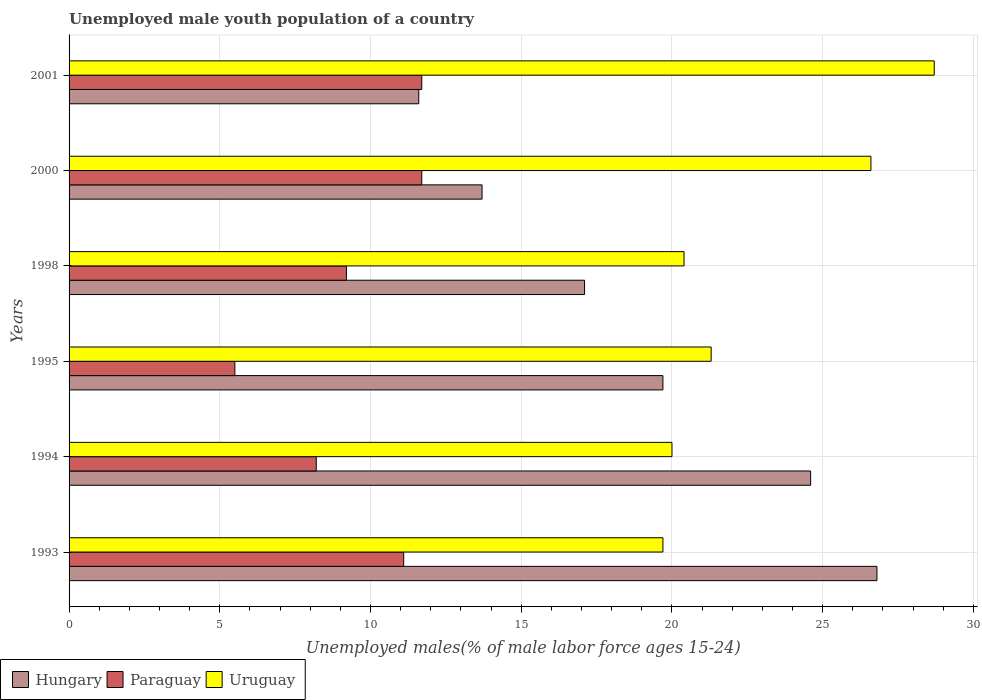How many different coloured bars are there?
Offer a very short reply. 3. How many groups of bars are there?
Make the answer very short. 6. Are the number of bars per tick equal to the number of legend labels?
Offer a terse response. Yes. How many bars are there on the 3rd tick from the bottom?
Your answer should be very brief. 3. What is the label of the 6th group of bars from the top?
Offer a very short reply. 1993. What is the percentage of unemployed male youth population in Paraguay in 1994?
Give a very brief answer. 8.2. Across all years, what is the maximum percentage of unemployed male youth population in Paraguay?
Make the answer very short. 11.7. Across all years, what is the minimum percentage of unemployed male youth population in Hungary?
Keep it short and to the point. 11.6. In which year was the percentage of unemployed male youth population in Paraguay maximum?
Give a very brief answer. 2000. In which year was the percentage of unemployed male youth population in Paraguay minimum?
Your response must be concise. 1995. What is the total percentage of unemployed male youth population in Paraguay in the graph?
Give a very brief answer. 57.4. What is the difference between the percentage of unemployed male youth population in Uruguay in 1993 and that in 1994?
Make the answer very short. -0.3. What is the average percentage of unemployed male youth population in Uruguay per year?
Your response must be concise. 22.78. In the year 1994, what is the difference between the percentage of unemployed male youth population in Hungary and percentage of unemployed male youth population in Paraguay?
Offer a terse response. 16.4. In how many years, is the percentage of unemployed male youth population in Uruguay greater than 9 %?
Your response must be concise. 6. What is the ratio of the percentage of unemployed male youth population in Uruguay in 1993 to that in 1995?
Offer a very short reply. 0.92. What is the difference between the highest and the second highest percentage of unemployed male youth population in Hungary?
Your answer should be compact. 2.2. What is the difference between the highest and the lowest percentage of unemployed male youth population in Hungary?
Your answer should be compact. 15.2. What does the 1st bar from the top in 2000 represents?
Offer a very short reply. Uruguay. What does the 1st bar from the bottom in 1993 represents?
Provide a short and direct response. Hungary. Are all the bars in the graph horizontal?
Ensure brevity in your answer.  Yes. How many years are there in the graph?
Ensure brevity in your answer.  6. Does the graph contain any zero values?
Provide a succinct answer. No. Where does the legend appear in the graph?
Keep it short and to the point. Bottom left. How many legend labels are there?
Give a very brief answer. 3. What is the title of the graph?
Offer a terse response. Unemployed male youth population of a country. Does "Mauritius" appear as one of the legend labels in the graph?
Provide a succinct answer. No. What is the label or title of the X-axis?
Ensure brevity in your answer.  Unemployed males(% of male labor force ages 15-24). What is the label or title of the Y-axis?
Provide a short and direct response. Years. What is the Unemployed males(% of male labor force ages 15-24) of Hungary in 1993?
Ensure brevity in your answer.  26.8. What is the Unemployed males(% of male labor force ages 15-24) in Paraguay in 1993?
Give a very brief answer. 11.1. What is the Unemployed males(% of male labor force ages 15-24) in Uruguay in 1993?
Offer a very short reply. 19.7. What is the Unemployed males(% of male labor force ages 15-24) in Hungary in 1994?
Offer a very short reply. 24.6. What is the Unemployed males(% of male labor force ages 15-24) in Paraguay in 1994?
Your answer should be compact. 8.2. What is the Unemployed males(% of male labor force ages 15-24) in Hungary in 1995?
Your answer should be compact. 19.7. What is the Unemployed males(% of male labor force ages 15-24) of Paraguay in 1995?
Your answer should be very brief. 5.5. What is the Unemployed males(% of male labor force ages 15-24) of Uruguay in 1995?
Your answer should be very brief. 21.3. What is the Unemployed males(% of male labor force ages 15-24) in Hungary in 1998?
Your answer should be compact. 17.1. What is the Unemployed males(% of male labor force ages 15-24) of Paraguay in 1998?
Your response must be concise. 9.2. What is the Unemployed males(% of male labor force ages 15-24) of Uruguay in 1998?
Your answer should be compact. 20.4. What is the Unemployed males(% of male labor force ages 15-24) in Hungary in 2000?
Offer a terse response. 13.7. What is the Unemployed males(% of male labor force ages 15-24) of Paraguay in 2000?
Your response must be concise. 11.7. What is the Unemployed males(% of male labor force ages 15-24) of Uruguay in 2000?
Ensure brevity in your answer.  26.6. What is the Unemployed males(% of male labor force ages 15-24) of Hungary in 2001?
Offer a terse response. 11.6. What is the Unemployed males(% of male labor force ages 15-24) of Paraguay in 2001?
Give a very brief answer. 11.7. What is the Unemployed males(% of male labor force ages 15-24) in Uruguay in 2001?
Offer a terse response. 28.7. Across all years, what is the maximum Unemployed males(% of male labor force ages 15-24) in Hungary?
Your answer should be compact. 26.8. Across all years, what is the maximum Unemployed males(% of male labor force ages 15-24) in Paraguay?
Provide a short and direct response. 11.7. Across all years, what is the maximum Unemployed males(% of male labor force ages 15-24) in Uruguay?
Keep it short and to the point. 28.7. Across all years, what is the minimum Unemployed males(% of male labor force ages 15-24) in Hungary?
Give a very brief answer. 11.6. Across all years, what is the minimum Unemployed males(% of male labor force ages 15-24) in Paraguay?
Offer a very short reply. 5.5. Across all years, what is the minimum Unemployed males(% of male labor force ages 15-24) of Uruguay?
Provide a short and direct response. 19.7. What is the total Unemployed males(% of male labor force ages 15-24) in Hungary in the graph?
Give a very brief answer. 113.5. What is the total Unemployed males(% of male labor force ages 15-24) of Paraguay in the graph?
Offer a terse response. 57.4. What is the total Unemployed males(% of male labor force ages 15-24) of Uruguay in the graph?
Your response must be concise. 136.7. What is the difference between the Unemployed males(% of male labor force ages 15-24) in Paraguay in 1993 and that in 1994?
Offer a very short reply. 2.9. What is the difference between the Unemployed males(% of male labor force ages 15-24) in Uruguay in 1993 and that in 1994?
Provide a succinct answer. -0.3. What is the difference between the Unemployed males(% of male labor force ages 15-24) of Uruguay in 1993 and that in 1995?
Offer a terse response. -1.6. What is the difference between the Unemployed males(% of male labor force ages 15-24) in Hungary in 1993 and that in 1998?
Make the answer very short. 9.7. What is the difference between the Unemployed males(% of male labor force ages 15-24) of Paraguay in 1993 and that in 1998?
Offer a terse response. 1.9. What is the difference between the Unemployed males(% of male labor force ages 15-24) of Paraguay in 1993 and that in 2000?
Offer a very short reply. -0.6. What is the difference between the Unemployed males(% of male labor force ages 15-24) in Paraguay in 1993 and that in 2001?
Your answer should be compact. -0.6. What is the difference between the Unemployed males(% of male labor force ages 15-24) in Uruguay in 1993 and that in 2001?
Your response must be concise. -9. What is the difference between the Unemployed males(% of male labor force ages 15-24) in Hungary in 1994 and that in 1995?
Keep it short and to the point. 4.9. What is the difference between the Unemployed males(% of male labor force ages 15-24) in Paraguay in 1994 and that in 1995?
Ensure brevity in your answer.  2.7. What is the difference between the Unemployed males(% of male labor force ages 15-24) of Hungary in 1994 and that in 1998?
Your answer should be compact. 7.5. What is the difference between the Unemployed males(% of male labor force ages 15-24) in Hungary in 1994 and that in 2000?
Your answer should be compact. 10.9. What is the difference between the Unemployed males(% of male labor force ages 15-24) of Uruguay in 1994 and that in 2000?
Offer a terse response. -6.6. What is the difference between the Unemployed males(% of male labor force ages 15-24) in Uruguay in 1994 and that in 2001?
Provide a succinct answer. -8.7. What is the difference between the Unemployed males(% of male labor force ages 15-24) of Paraguay in 1995 and that in 1998?
Provide a short and direct response. -3.7. What is the difference between the Unemployed males(% of male labor force ages 15-24) in Paraguay in 1995 and that in 2000?
Offer a very short reply. -6.2. What is the difference between the Unemployed males(% of male labor force ages 15-24) in Paraguay in 1998 and that in 2000?
Keep it short and to the point. -2.5. What is the difference between the Unemployed males(% of male labor force ages 15-24) of Uruguay in 1998 and that in 2000?
Provide a succinct answer. -6.2. What is the difference between the Unemployed males(% of male labor force ages 15-24) of Paraguay in 2000 and that in 2001?
Your answer should be compact. 0. What is the difference between the Unemployed males(% of male labor force ages 15-24) of Paraguay in 1993 and the Unemployed males(% of male labor force ages 15-24) of Uruguay in 1994?
Make the answer very short. -8.9. What is the difference between the Unemployed males(% of male labor force ages 15-24) in Hungary in 1993 and the Unemployed males(% of male labor force ages 15-24) in Paraguay in 1995?
Give a very brief answer. 21.3. What is the difference between the Unemployed males(% of male labor force ages 15-24) in Hungary in 1993 and the Unemployed males(% of male labor force ages 15-24) in Uruguay in 1995?
Ensure brevity in your answer.  5.5. What is the difference between the Unemployed males(% of male labor force ages 15-24) of Hungary in 1993 and the Unemployed males(% of male labor force ages 15-24) of Paraguay in 1998?
Ensure brevity in your answer.  17.6. What is the difference between the Unemployed males(% of male labor force ages 15-24) in Paraguay in 1993 and the Unemployed males(% of male labor force ages 15-24) in Uruguay in 1998?
Your response must be concise. -9.3. What is the difference between the Unemployed males(% of male labor force ages 15-24) in Hungary in 1993 and the Unemployed males(% of male labor force ages 15-24) in Uruguay in 2000?
Give a very brief answer. 0.2. What is the difference between the Unemployed males(% of male labor force ages 15-24) in Paraguay in 1993 and the Unemployed males(% of male labor force ages 15-24) in Uruguay in 2000?
Give a very brief answer. -15.5. What is the difference between the Unemployed males(% of male labor force ages 15-24) in Paraguay in 1993 and the Unemployed males(% of male labor force ages 15-24) in Uruguay in 2001?
Your response must be concise. -17.6. What is the difference between the Unemployed males(% of male labor force ages 15-24) in Hungary in 1994 and the Unemployed males(% of male labor force ages 15-24) in Uruguay in 1998?
Give a very brief answer. 4.2. What is the difference between the Unemployed males(% of male labor force ages 15-24) of Paraguay in 1994 and the Unemployed males(% of male labor force ages 15-24) of Uruguay in 1998?
Make the answer very short. -12.2. What is the difference between the Unemployed males(% of male labor force ages 15-24) in Hungary in 1994 and the Unemployed males(% of male labor force ages 15-24) in Uruguay in 2000?
Your response must be concise. -2. What is the difference between the Unemployed males(% of male labor force ages 15-24) in Paraguay in 1994 and the Unemployed males(% of male labor force ages 15-24) in Uruguay in 2000?
Give a very brief answer. -18.4. What is the difference between the Unemployed males(% of male labor force ages 15-24) in Hungary in 1994 and the Unemployed males(% of male labor force ages 15-24) in Uruguay in 2001?
Your answer should be very brief. -4.1. What is the difference between the Unemployed males(% of male labor force ages 15-24) in Paraguay in 1994 and the Unemployed males(% of male labor force ages 15-24) in Uruguay in 2001?
Provide a succinct answer. -20.5. What is the difference between the Unemployed males(% of male labor force ages 15-24) in Hungary in 1995 and the Unemployed males(% of male labor force ages 15-24) in Uruguay in 1998?
Your answer should be very brief. -0.7. What is the difference between the Unemployed males(% of male labor force ages 15-24) of Paraguay in 1995 and the Unemployed males(% of male labor force ages 15-24) of Uruguay in 1998?
Your answer should be compact. -14.9. What is the difference between the Unemployed males(% of male labor force ages 15-24) in Hungary in 1995 and the Unemployed males(% of male labor force ages 15-24) in Paraguay in 2000?
Offer a terse response. 8. What is the difference between the Unemployed males(% of male labor force ages 15-24) of Paraguay in 1995 and the Unemployed males(% of male labor force ages 15-24) of Uruguay in 2000?
Keep it short and to the point. -21.1. What is the difference between the Unemployed males(% of male labor force ages 15-24) of Hungary in 1995 and the Unemployed males(% of male labor force ages 15-24) of Paraguay in 2001?
Provide a short and direct response. 8. What is the difference between the Unemployed males(% of male labor force ages 15-24) of Paraguay in 1995 and the Unemployed males(% of male labor force ages 15-24) of Uruguay in 2001?
Offer a very short reply. -23.2. What is the difference between the Unemployed males(% of male labor force ages 15-24) of Paraguay in 1998 and the Unemployed males(% of male labor force ages 15-24) of Uruguay in 2000?
Offer a very short reply. -17.4. What is the difference between the Unemployed males(% of male labor force ages 15-24) in Paraguay in 1998 and the Unemployed males(% of male labor force ages 15-24) in Uruguay in 2001?
Offer a terse response. -19.5. What is the difference between the Unemployed males(% of male labor force ages 15-24) in Hungary in 2000 and the Unemployed males(% of male labor force ages 15-24) in Uruguay in 2001?
Your answer should be very brief. -15. What is the difference between the Unemployed males(% of male labor force ages 15-24) of Paraguay in 2000 and the Unemployed males(% of male labor force ages 15-24) of Uruguay in 2001?
Provide a short and direct response. -17. What is the average Unemployed males(% of male labor force ages 15-24) in Hungary per year?
Make the answer very short. 18.92. What is the average Unemployed males(% of male labor force ages 15-24) of Paraguay per year?
Your answer should be very brief. 9.57. What is the average Unemployed males(% of male labor force ages 15-24) in Uruguay per year?
Your response must be concise. 22.78. In the year 1993, what is the difference between the Unemployed males(% of male labor force ages 15-24) in Hungary and Unemployed males(% of male labor force ages 15-24) in Paraguay?
Ensure brevity in your answer.  15.7. In the year 1993, what is the difference between the Unemployed males(% of male labor force ages 15-24) in Hungary and Unemployed males(% of male labor force ages 15-24) in Uruguay?
Offer a very short reply. 7.1. In the year 1994, what is the difference between the Unemployed males(% of male labor force ages 15-24) in Hungary and Unemployed males(% of male labor force ages 15-24) in Uruguay?
Provide a succinct answer. 4.6. In the year 1994, what is the difference between the Unemployed males(% of male labor force ages 15-24) of Paraguay and Unemployed males(% of male labor force ages 15-24) of Uruguay?
Your answer should be very brief. -11.8. In the year 1995, what is the difference between the Unemployed males(% of male labor force ages 15-24) in Hungary and Unemployed males(% of male labor force ages 15-24) in Paraguay?
Offer a very short reply. 14.2. In the year 1995, what is the difference between the Unemployed males(% of male labor force ages 15-24) in Paraguay and Unemployed males(% of male labor force ages 15-24) in Uruguay?
Your answer should be compact. -15.8. In the year 2000, what is the difference between the Unemployed males(% of male labor force ages 15-24) of Hungary and Unemployed males(% of male labor force ages 15-24) of Paraguay?
Offer a very short reply. 2. In the year 2000, what is the difference between the Unemployed males(% of male labor force ages 15-24) in Paraguay and Unemployed males(% of male labor force ages 15-24) in Uruguay?
Your answer should be compact. -14.9. In the year 2001, what is the difference between the Unemployed males(% of male labor force ages 15-24) of Hungary and Unemployed males(% of male labor force ages 15-24) of Uruguay?
Make the answer very short. -17.1. In the year 2001, what is the difference between the Unemployed males(% of male labor force ages 15-24) of Paraguay and Unemployed males(% of male labor force ages 15-24) of Uruguay?
Provide a short and direct response. -17. What is the ratio of the Unemployed males(% of male labor force ages 15-24) in Hungary in 1993 to that in 1994?
Ensure brevity in your answer.  1.09. What is the ratio of the Unemployed males(% of male labor force ages 15-24) of Paraguay in 1993 to that in 1994?
Provide a succinct answer. 1.35. What is the ratio of the Unemployed males(% of male labor force ages 15-24) of Hungary in 1993 to that in 1995?
Give a very brief answer. 1.36. What is the ratio of the Unemployed males(% of male labor force ages 15-24) in Paraguay in 1993 to that in 1995?
Offer a very short reply. 2.02. What is the ratio of the Unemployed males(% of male labor force ages 15-24) of Uruguay in 1993 to that in 1995?
Offer a very short reply. 0.92. What is the ratio of the Unemployed males(% of male labor force ages 15-24) in Hungary in 1993 to that in 1998?
Provide a succinct answer. 1.57. What is the ratio of the Unemployed males(% of male labor force ages 15-24) in Paraguay in 1993 to that in 1998?
Your answer should be compact. 1.21. What is the ratio of the Unemployed males(% of male labor force ages 15-24) in Uruguay in 1993 to that in 1998?
Give a very brief answer. 0.97. What is the ratio of the Unemployed males(% of male labor force ages 15-24) of Hungary in 1993 to that in 2000?
Offer a terse response. 1.96. What is the ratio of the Unemployed males(% of male labor force ages 15-24) in Paraguay in 1993 to that in 2000?
Provide a succinct answer. 0.95. What is the ratio of the Unemployed males(% of male labor force ages 15-24) in Uruguay in 1993 to that in 2000?
Your answer should be compact. 0.74. What is the ratio of the Unemployed males(% of male labor force ages 15-24) of Hungary in 1993 to that in 2001?
Provide a succinct answer. 2.31. What is the ratio of the Unemployed males(% of male labor force ages 15-24) of Paraguay in 1993 to that in 2001?
Make the answer very short. 0.95. What is the ratio of the Unemployed males(% of male labor force ages 15-24) in Uruguay in 1993 to that in 2001?
Offer a terse response. 0.69. What is the ratio of the Unemployed males(% of male labor force ages 15-24) in Hungary in 1994 to that in 1995?
Give a very brief answer. 1.25. What is the ratio of the Unemployed males(% of male labor force ages 15-24) of Paraguay in 1994 to that in 1995?
Offer a terse response. 1.49. What is the ratio of the Unemployed males(% of male labor force ages 15-24) in Uruguay in 1994 to that in 1995?
Offer a very short reply. 0.94. What is the ratio of the Unemployed males(% of male labor force ages 15-24) in Hungary in 1994 to that in 1998?
Make the answer very short. 1.44. What is the ratio of the Unemployed males(% of male labor force ages 15-24) of Paraguay in 1994 to that in 1998?
Keep it short and to the point. 0.89. What is the ratio of the Unemployed males(% of male labor force ages 15-24) of Uruguay in 1994 to that in 1998?
Your answer should be compact. 0.98. What is the ratio of the Unemployed males(% of male labor force ages 15-24) in Hungary in 1994 to that in 2000?
Provide a succinct answer. 1.8. What is the ratio of the Unemployed males(% of male labor force ages 15-24) in Paraguay in 1994 to that in 2000?
Your answer should be compact. 0.7. What is the ratio of the Unemployed males(% of male labor force ages 15-24) of Uruguay in 1994 to that in 2000?
Your response must be concise. 0.75. What is the ratio of the Unemployed males(% of male labor force ages 15-24) in Hungary in 1994 to that in 2001?
Your answer should be very brief. 2.12. What is the ratio of the Unemployed males(% of male labor force ages 15-24) of Paraguay in 1994 to that in 2001?
Provide a short and direct response. 0.7. What is the ratio of the Unemployed males(% of male labor force ages 15-24) in Uruguay in 1994 to that in 2001?
Make the answer very short. 0.7. What is the ratio of the Unemployed males(% of male labor force ages 15-24) in Hungary in 1995 to that in 1998?
Give a very brief answer. 1.15. What is the ratio of the Unemployed males(% of male labor force ages 15-24) in Paraguay in 1995 to that in 1998?
Offer a terse response. 0.6. What is the ratio of the Unemployed males(% of male labor force ages 15-24) in Uruguay in 1995 to that in 1998?
Make the answer very short. 1.04. What is the ratio of the Unemployed males(% of male labor force ages 15-24) in Hungary in 1995 to that in 2000?
Offer a very short reply. 1.44. What is the ratio of the Unemployed males(% of male labor force ages 15-24) of Paraguay in 1995 to that in 2000?
Your answer should be very brief. 0.47. What is the ratio of the Unemployed males(% of male labor force ages 15-24) in Uruguay in 1995 to that in 2000?
Your response must be concise. 0.8. What is the ratio of the Unemployed males(% of male labor force ages 15-24) in Hungary in 1995 to that in 2001?
Offer a very short reply. 1.7. What is the ratio of the Unemployed males(% of male labor force ages 15-24) of Paraguay in 1995 to that in 2001?
Offer a terse response. 0.47. What is the ratio of the Unemployed males(% of male labor force ages 15-24) of Uruguay in 1995 to that in 2001?
Offer a terse response. 0.74. What is the ratio of the Unemployed males(% of male labor force ages 15-24) in Hungary in 1998 to that in 2000?
Your answer should be very brief. 1.25. What is the ratio of the Unemployed males(% of male labor force ages 15-24) in Paraguay in 1998 to that in 2000?
Offer a very short reply. 0.79. What is the ratio of the Unemployed males(% of male labor force ages 15-24) of Uruguay in 1998 to that in 2000?
Give a very brief answer. 0.77. What is the ratio of the Unemployed males(% of male labor force ages 15-24) in Hungary in 1998 to that in 2001?
Your answer should be very brief. 1.47. What is the ratio of the Unemployed males(% of male labor force ages 15-24) of Paraguay in 1998 to that in 2001?
Ensure brevity in your answer.  0.79. What is the ratio of the Unemployed males(% of male labor force ages 15-24) of Uruguay in 1998 to that in 2001?
Ensure brevity in your answer.  0.71. What is the ratio of the Unemployed males(% of male labor force ages 15-24) of Hungary in 2000 to that in 2001?
Your response must be concise. 1.18. What is the ratio of the Unemployed males(% of male labor force ages 15-24) of Paraguay in 2000 to that in 2001?
Ensure brevity in your answer.  1. What is the ratio of the Unemployed males(% of male labor force ages 15-24) in Uruguay in 2000 to that in 2001?
Offer a very short reply. 0.93. What is the difference between the highest and the lowest Unemployed males(% of male labor force ages 15-24) of Paraguay?
Make the answer very short. 6.2. 